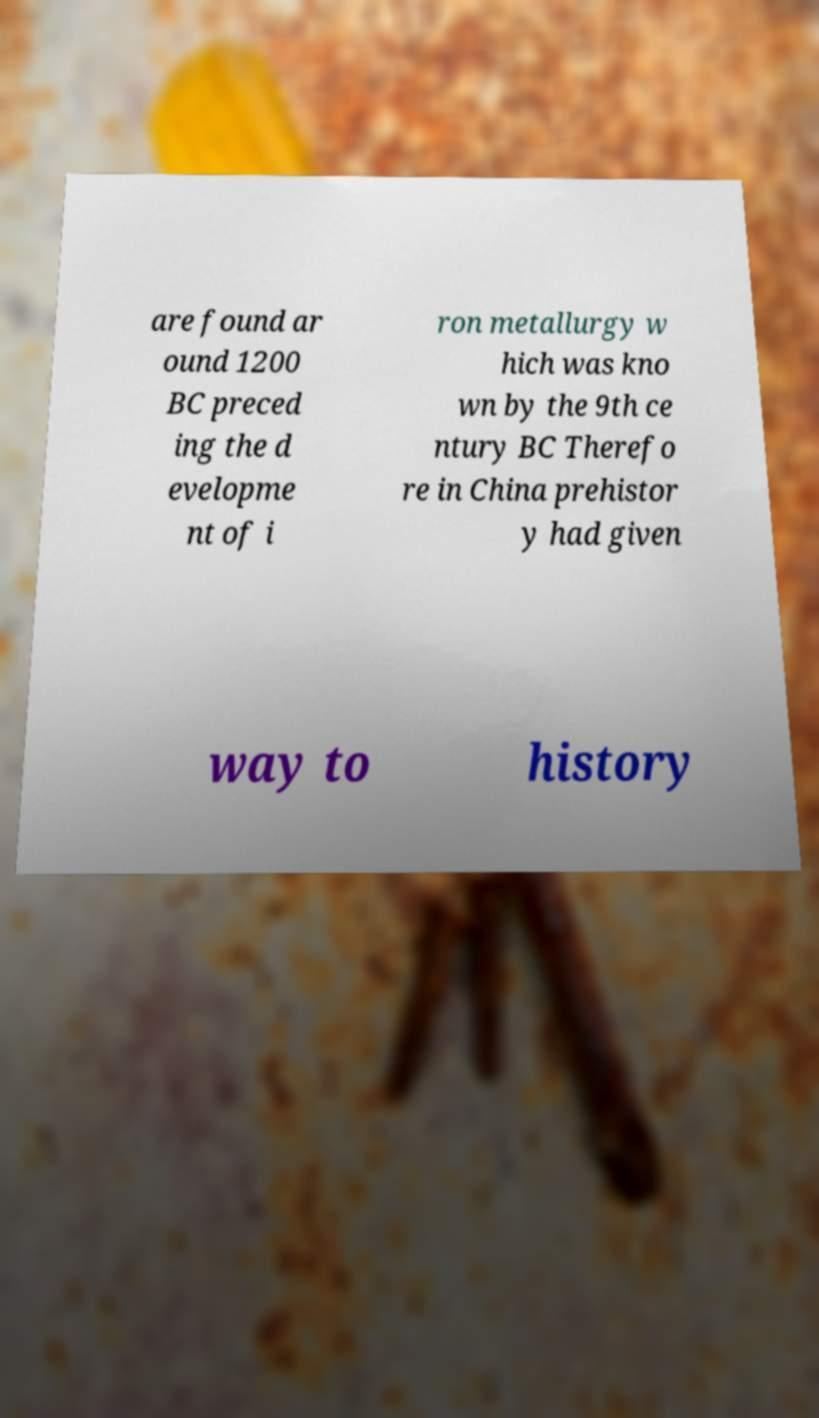For documentation purposes, I need the text within this image transcribed. Could you provide that? are found ar ound 1200 BC preced ing the d evelopme nt of i ron metallurgy w hich was kno wn by the 9th ce ntury BC Therefo re in China prehistor y had given way to history 